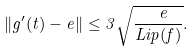Convert formula to latex. <formula><loc_0><loc_0><loc_500><loc_500>\| g ^ { \prime } ( t ) - e \| \leq 3 \sqrt { \frac { \ e } { L i p ( f ) } } .</formula> 